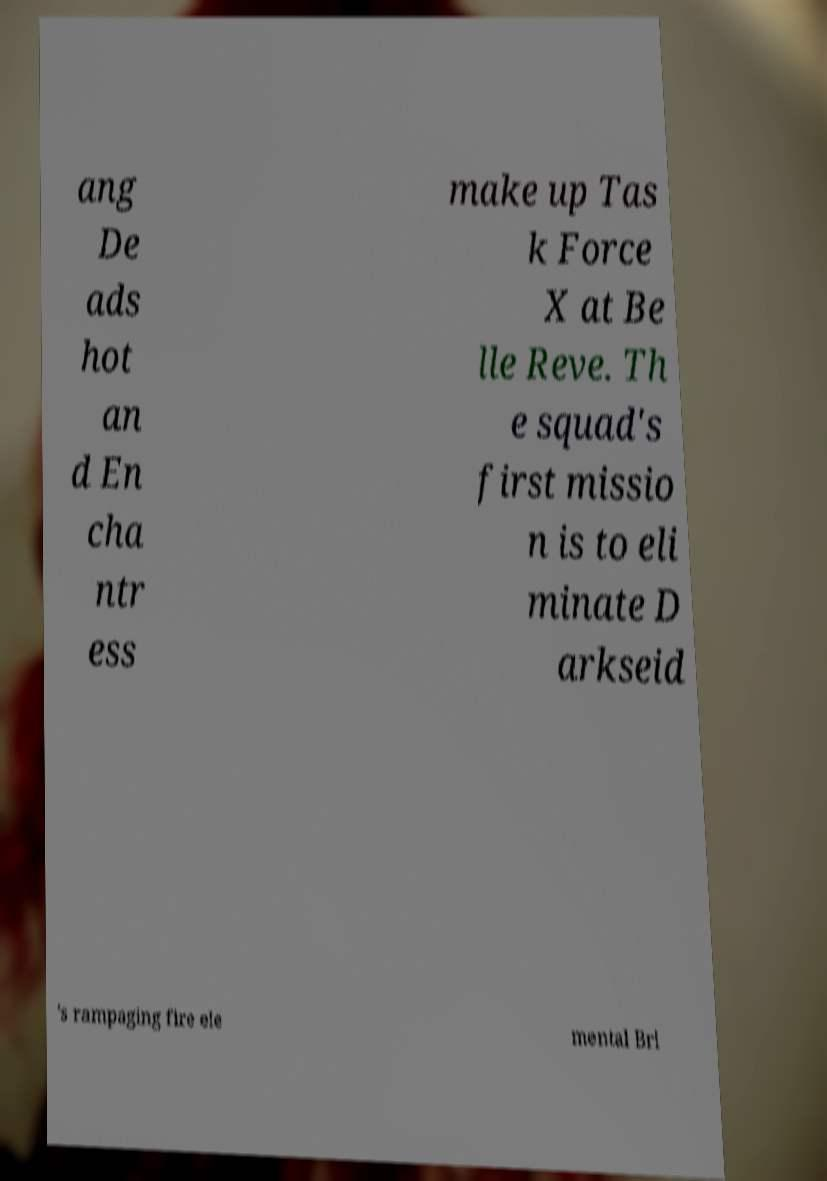There's text embedded in this image that I need extracted. Can you transcribe it verbatim? ang De ads hot an d En cha ntr ess make up Tas k Force X at Be lle Reve. Th e squad's first missio n is to eli minate D arkseid 's rampaging fire ele mental Bri 